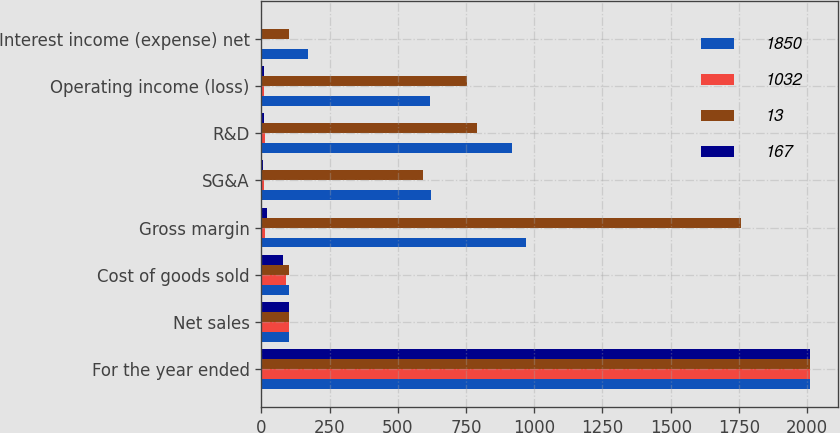Convert chart. <chart><loc_0><loc_0><loc_500><loc_500><stacked_bar_chart><ecel><fcel>For the year ended<fcel>Net sales<fcel>Cost of goods sold<fcel>Gross margin<fcel>SG&A<fcel>R&D<fcel>Operating income (loss)<fcel>Interest income (expense) net<nl><fcel>1850<fcel>2012<fcel>100.5<fcel>100.5<fcel>968<fcel>620<fcel>918<fcel>618<fcel>171<nl><fcel>1032<fcel>2012<fcel>100<fcel>88<fcel>12<fcel>8<fcel>11<fcel>8<fcel>2<nl><fcel>13<fcel>2011<fcel>100.5<fcel>100.5<fcel>1758<fcel>592<fcel>791<fcel>755<fcel>101<nl><fcel>167<fcel>2011<fcel>100<fcel>80<fcel>20<fcel>7<fcel>9<fcel>9<fcel>1<nl></chart> 